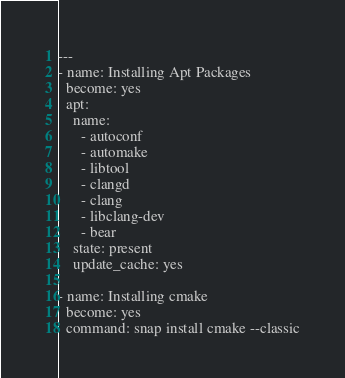Convert code to text. <code><loc_0><loc_0><loc_500><loc_500><_YAML_>---
- name: Installing Apt Packages
  become: yes
  apt:
    name:
      - autoconf
      - automake
      - libtool
      - clangd
      - clang
      - libclang-dev
      - bear
    state: present
    update_cache: yes

- name: Installing cmake
  become: yes
  command: snap install cmake --classic
</code> 